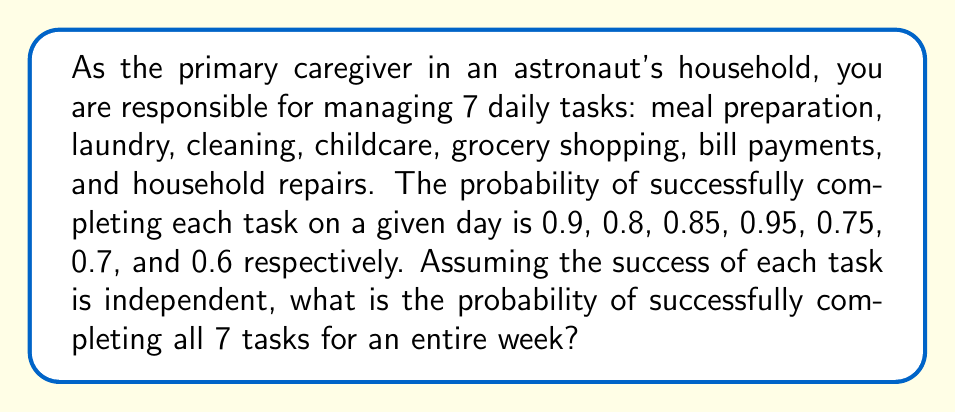Provide a solution to this math problem. To solve this problem, we need to follow these steps:

1) First, let's calculate the probability of completing all 7 tasks in a single day. Since the tasks are independent, we multiply their individual probabilities:

   $$P(\text{all tasks in one day}) = 0.9 \times 0.8 \times 0.85 \times 0.95 \times 0.75 \times 0.7 \times 0.6$$
   $$= 0.183708$$

2) Now, we need to consider that this needs to happen every day for a week (7 days). Again, assuming independence between days, we raise our daily probability to the power of 7:

   $$P(\text{all tasks for a week}) = (0.183708)^7$$

3) Let's calculate this:
   
   $$(0.183708)^7 \approx 1.874 \times 10^{-5}$$

This very small probability reflects the difficulty of consistently managing all household tasks perfectly for an entire week, especially with some tasks having lower individual probabilities of completion.
Answer: The probability of successfully completing all 7 household tasks for an entire week is approximately $1.874 \times 10^{-5}$ or about 0.001874%. 